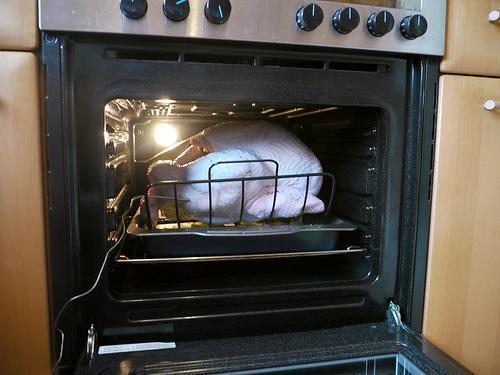How many ovens are shown?
Give a very brief answer. 1. 